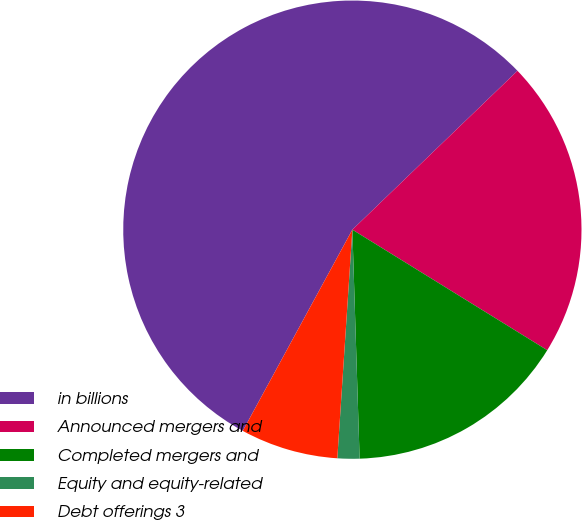Convert chart. <chart><loc_0><loc_0><loc_500><loc_500><pie_chart><fcel>in billions<fcel>Announced mergers and<fcel>Completed mergers and<fcel>Equity and equity-related<fcel>Debt offerings 3<nl><fcel>54.87%<fcel>21.01%<fcel>15.68%<fcel>1.55%<fcel>6.89%<nl></chart> 